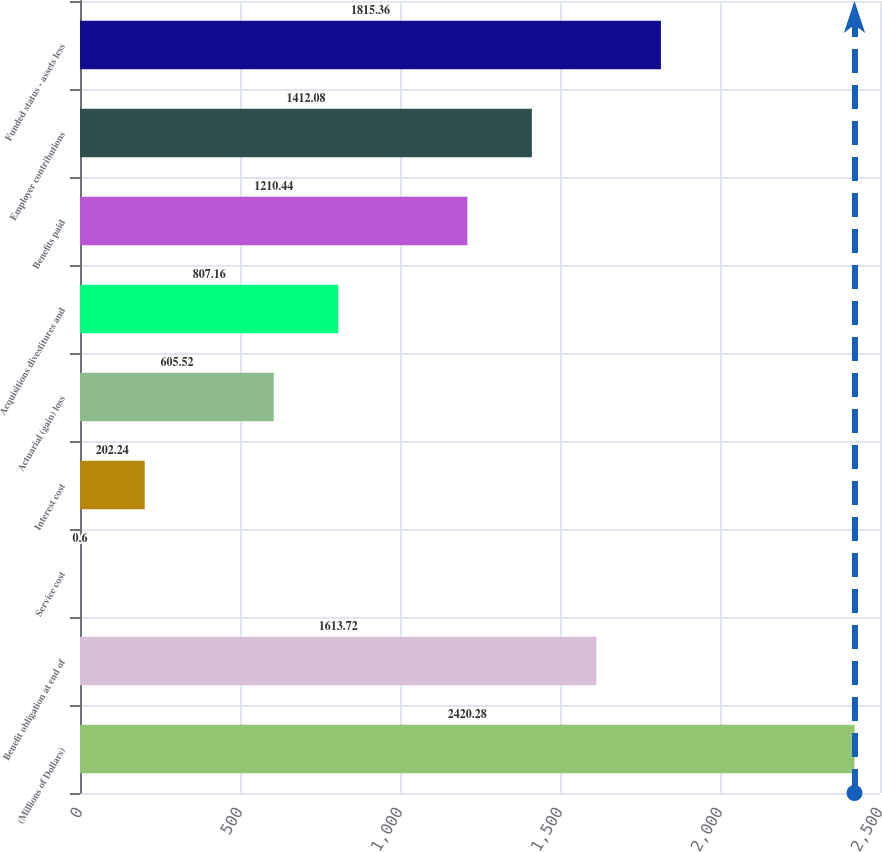<chart> <loc_0><loc_0><loc_500><loc_500><bar_chart><fcel>(Millions of Dollars)<fcel>Benefit obligation at end of<fcel>Service cost<fcel>Interest cost<fcel>Actuarial (gain) loss<fcel>Acquisitions divestitures and<fcel>Benefits paid<fcel>Employer contributions<fcel>Funded status - assets less<nl><fcel>2420.28<fcel>1613.72<fcel>0.6<fcel>202.24<fcel>605.52<fcel>807.16<fcel>1210.44<fcel>1412.08<fcel>1815.36<nl></chart> 